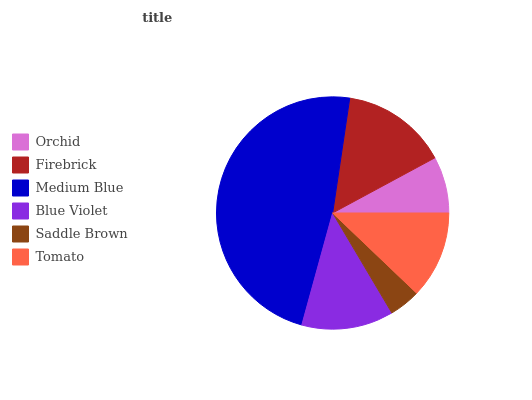Is Saddle Brown the minimum?
Answer yes or no. Yes. Is Medium Blue the maximum?
Answer yes or no. Yes. Is Firebrick the minimum?
Answer yes or no. No. Is Firebrick the maximum?
Answer yes or no. No. Is Firebrick greater than Orchid?
Answer yes or no. Yes. Is Orchid less than Firebrick?
Answer yes or no. Yes. Is Orchid greater than Firebrick?
Answer yes or no. No. Is Firebrick less than Orchid?
Answer yes or no. No. Is Blue Violet the high median?
Answer yes or no. Yes. Is Tomato the low median?
Answer yes or no. Yes. Is Medium Blue the high median?
Answer yes or no. No. Is Orchid the low median?
Answer yes or no. No. 